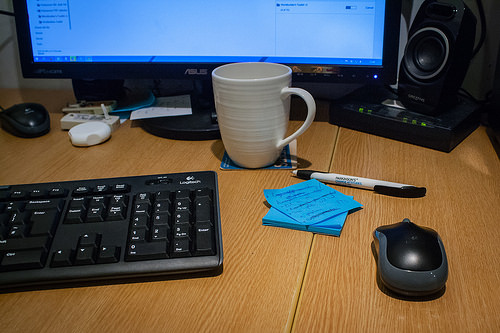<image>
Is the cup on the desk? Yes. Looking at the image, I can see the cup is positioned on top of the desk, with the desk providing support. 